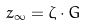<formula> <loc_0><loc_0><loc_500><loc_500>z _ { \infty } = \zeta \cdot G</formula> 